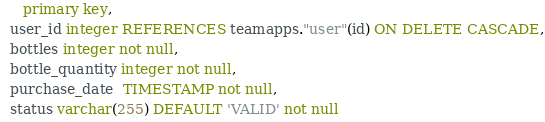Convert code to text. <code><loc_0><loc_0><loc_500><loc_500><_SQL_>     primary key,
  user_id integer REFERENCES teamapps."user"(id) ON DELETE CASCADE,
  bottles integer not null,
  bottle_quantity integer not null,
  purchase_date  TIMESTAMP not null,
  status varchar(255) DEFAULT 'VALID' not null</code> 